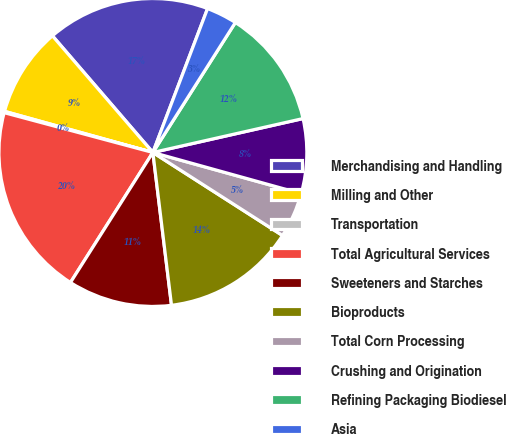<chart> <loc_0><loc_0><loc_500><loc_500><pie_chart><fcel>Merchandising and Handling<fcel>Milling and Other<fcel>Transportation<fcel>Total Agricultural Services<fcel>Sweeteners and Starches<fcel>Bioproducts<fcel>Total Corn Processing<fcel>Crushing and Origination<fcel>Refining Packaging Biodiesel<fcel>Asia<nl><fcel>17.09%<fcel>9.38%<fcel>0.14%<fcel>20.17%<fcel>10.92%<fcel>14.0%<fcel>4.76%<fcel>7.84%<fcel>12.46%<fcel>3.22%<nl></chart> 